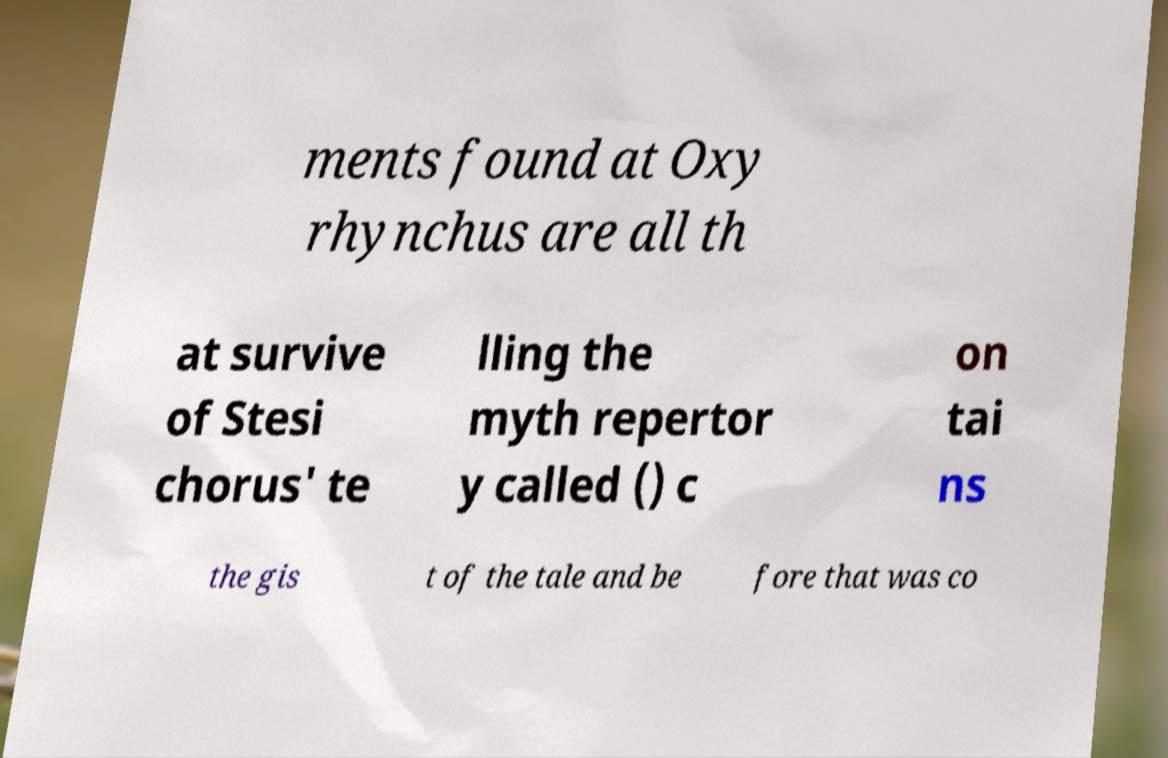I need the written content from this picture converted into text. Can you do that? ments found at Oxy rhynchus are all th at survive of Stesi chorus' te lling the myth repertor y called () c on tai ns the gis t of the tale and be fore that was co 